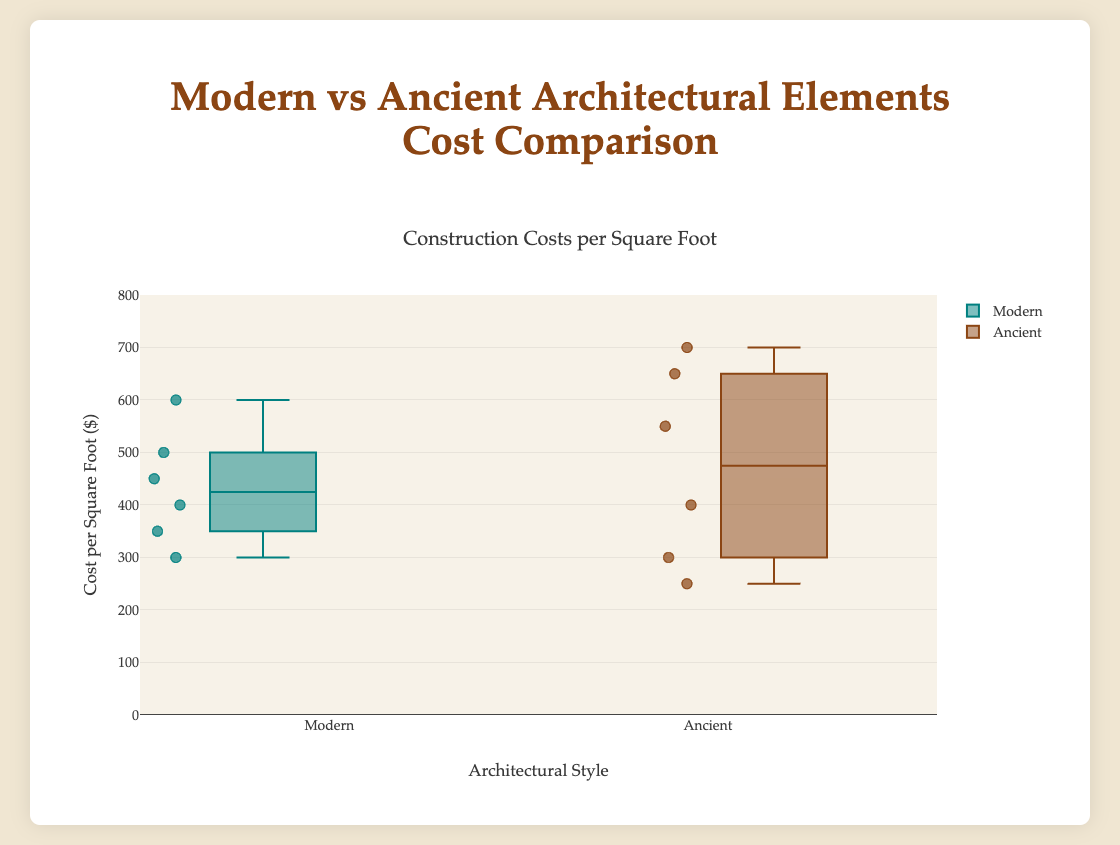What is the title of the figure? The title of the figure is prominently displayed at the top of the plot.
Answer: Construction Costs per Square Foot What are the median costs for Modern and Ancient architectural elements? To find the medians, look at the middle line in each of the box plots — these represent the median values for Modern and Ancient costs.
Answer: Median for Modern: 425, Median for Ancient: 475 Which architectural style has the higher maximum cost per square foot? The highest points at the top of each box plot represent the maximum costs. Compare these highest points for both styles.
Answer: Ancient What is the range of costs for Ancient architectural elements? The range is found by subtracting the minimum cost from the maximum cost for Ancient elements, which can be identified by the bottom and top points of the Ancient box plot.
Answer: 450 (700 - 250) Which Modern element has the highest cost? The markers in the Modern box plot represent individual costs. The highest marker indicates the highest cost element within the Modern category.
Answer: 3D Printed Elements How much higher is the maximum cost for Ancient than for Modern architectural elements? Determine the maximum costs for both styles from the plot and subtract the Modern maximum from the Ancient maximum.
Answer: 100 (700 - 600) Are there more data points in the Modern or Ancient category? Count the markers (points) within each box plot.
Answer: Equal (both have 6) Which architectural style shows greater variability in costs? Variability can be assessed by looking at the interquartile range (IQR), which is the length of the box. The longer the box, the greater the variability.
Answer: Ancient What is the interquartile range (IQR) for the Modern architectural elements? The IQR is the distance between the first quartile (bottom of the box) and the third quartile (top of the box) for the Modern box plot.
Answer: 150 (500 - 350) Which architectural style has the higher median cost per square foot? The middle line inside each box plot represents the median. Compare the positions of these lines between the two styles.
Answer: Ancient 